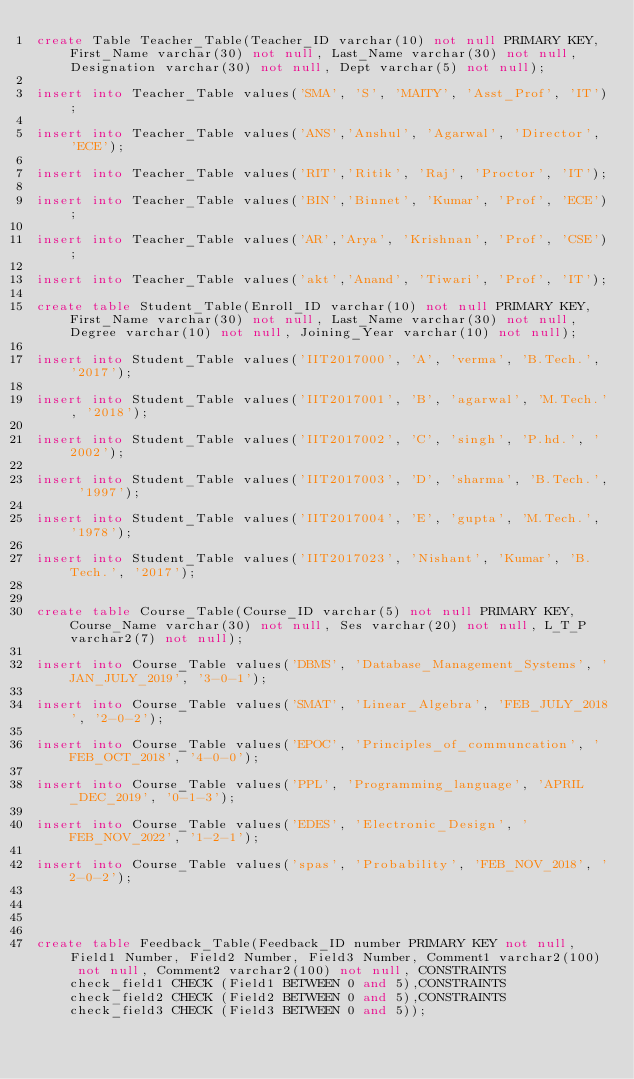Convert code to text. <code><loc_0><loc_0><loc_500><loc_500><_SQL_>create Table Teacher_Table(Teacher_ID varchar(10) not null PRIMARY KEY, First_Name varchar(30) not null, Last_Name varchar(30) not null, Designation varchar(30) not null, Dept varchar(5) not null);

insert into Teacher_Table values('SMA', 'S', 'MAITY', 'Asst_Prof', 'IT');

insert into Teacher_Table values('ANS','Anshul', 'Agarwal', 'Director', 'ECE');

insert into Teacher_Table values('RIT','Ritik', 'Raj', 'Proctor', 'IT');

insert into Teacher_Table values('BIN','Binnet', 'Kumar', 'Prof', 'ECE');

insert into Teacher_Table values('AR','Arya', 'Krishnan', 'Prof', 'CSE');

insert into Teacher_Table values('akt','Anand', 'Tiwari', 'Prof', 'IT');

create table Student_Table(Enroll_ID varchar(10) not null PRIMARY KEY, First_Name varchar(30) not null, Last_Name varchar(30) not null, Degree varchar(10) not null, Joining_Year varchar(10) not null);

insert into Student_Table values('IIT2017000', 'A', 'verma', 'B.Tech.', '2017');

insert into Student_Table values('IIT2017001', 'B', 'agarwal', 'M.Tech.', '2018');

insert into Student_Table values('IIT2017002', 'C', 'singh', 'P.hd.', '2002');

insert into Student_Table values('IIT2017003', 'D', 'sharma', 'B.Tech.', '1997');

insert into Student_Table values('IIT2017004', 'E', 'gupta', 'M.Tech.', '1978');

insert into Student_Table values('IIT2017023', 'Nishant', 'Kumar', 'B.Tech.', '2017');	


create table Course_Table(Course_ID varchar(5) not null PRIMARY KEY, Course_Name varchar(30) not null, Ses varchar(20) not null, L_T_P varchar2(7) not null);

insert into Course_Table values('DBMS', 'Database_Management_Systems', 'JAN_JULY_2019', '3-0-1');

insert into Course_Table values('SMAT', 'Linear_Algebra', 'FEB_JULY_2018', '2-0-2');

insert into Course_Table values('EPOC', 'Principles_of_communcation', 'FEB_OCT_2018', '4-0-0');

insert into Course_Table values('PPL', 'Programming_language', 'APRIL	_DEC_2019', '0-1-3');

insert into Course_Table values('EDES', 'Electronic_Design', 'FEB_NOV_2022', '1-2-1');

insert into Course_Table values('spas', 'Probability', 'FEB_NOV_2018', '2-0-2');




create table Feedback_Table(Feedback_ID number PRIMARY KEY not null,Field1 Number, Field2 Number, Field3 Number, Comment1 varchar2(100) not null, Comment2 varchar2(100) not null, CONSTRAINTS check_field1 CHECK (Field1 BETWEEN 0 and 5),CONSTRAINTS check_field2 CHECK (Field2 BETWEEN 0 and 5),CONSTRAINTS check_field3 CHECK (Field3 BETWEEN 0 and 5));
</code> 